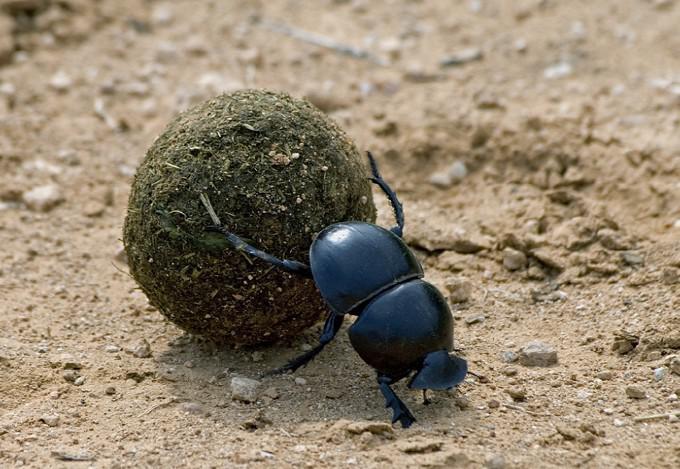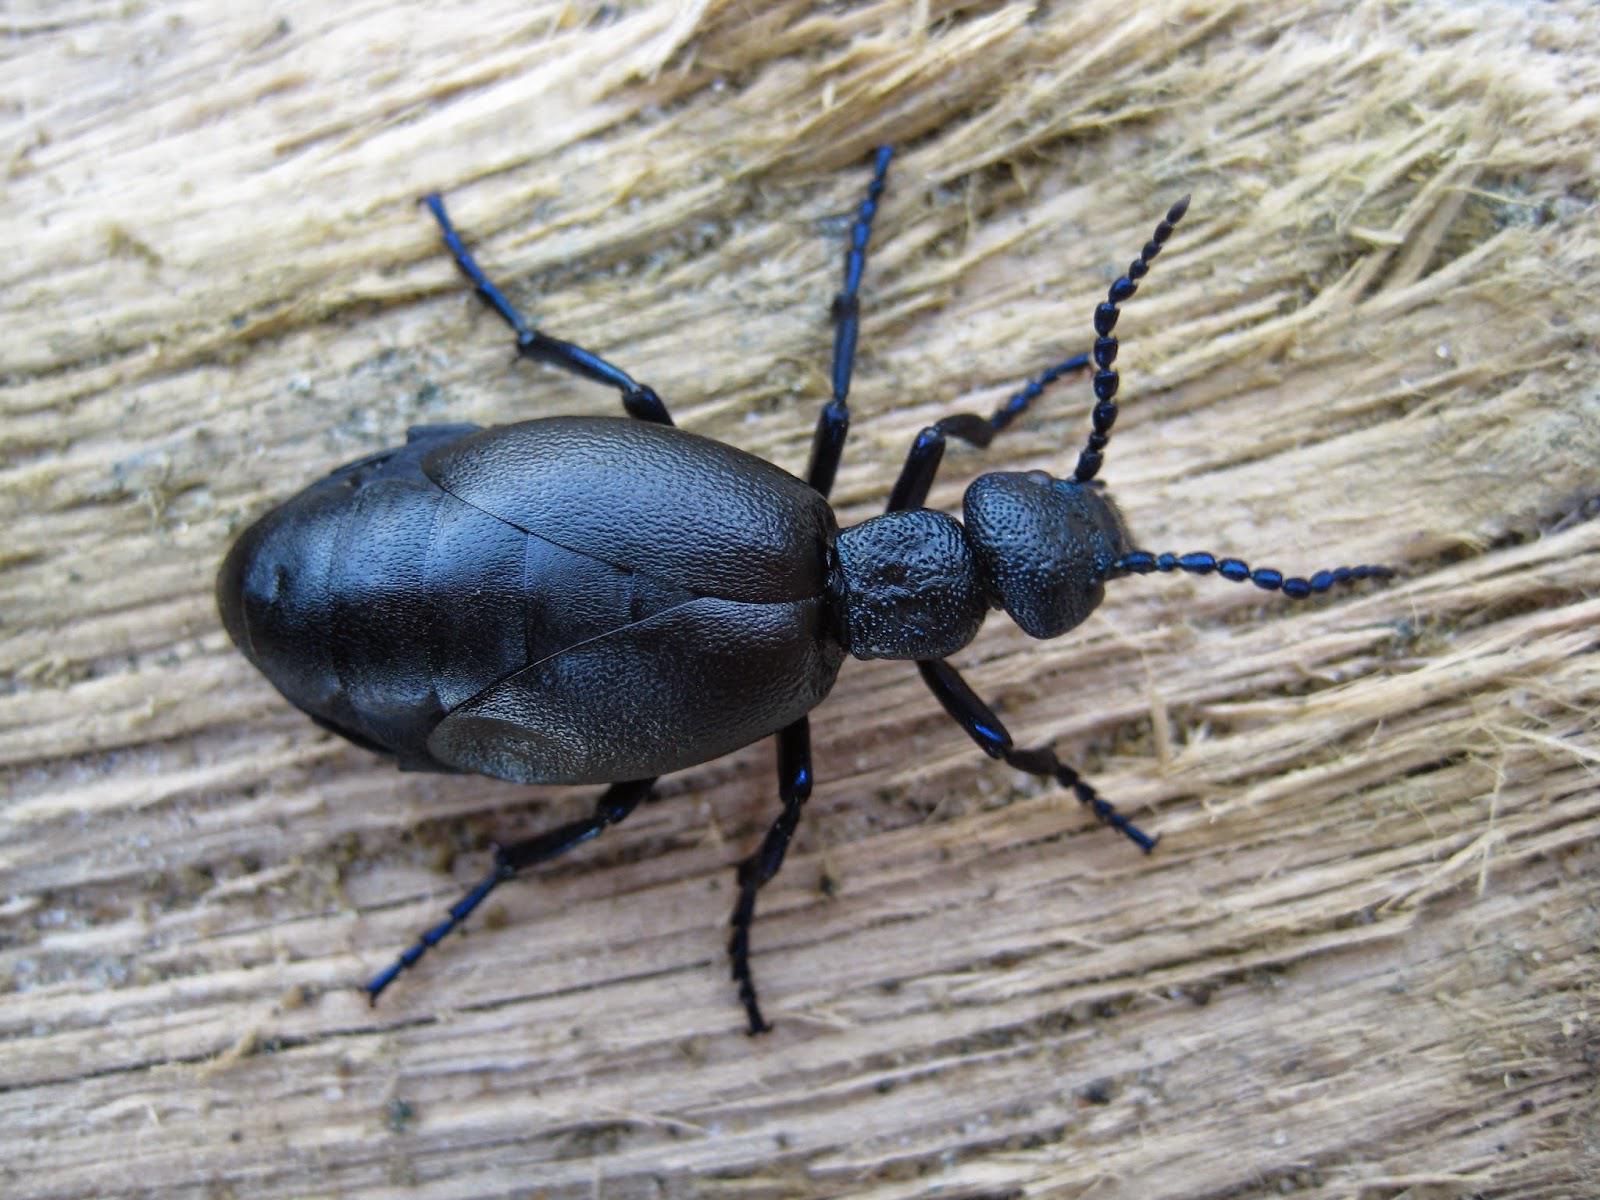The first image is the image on the left, the second image is the image on the right. Considering the images on both sides, is "There are at most three beetles." valid? Answer yes or no. Yes. The first image is the image on the left, the second image is the image on the right. Examine the images to the left and right. Is the description "One image contains a black beetle but no brown ball, and the other contains one brown ball and at least one beetle." accurate? Answer yes or no. Yes. 